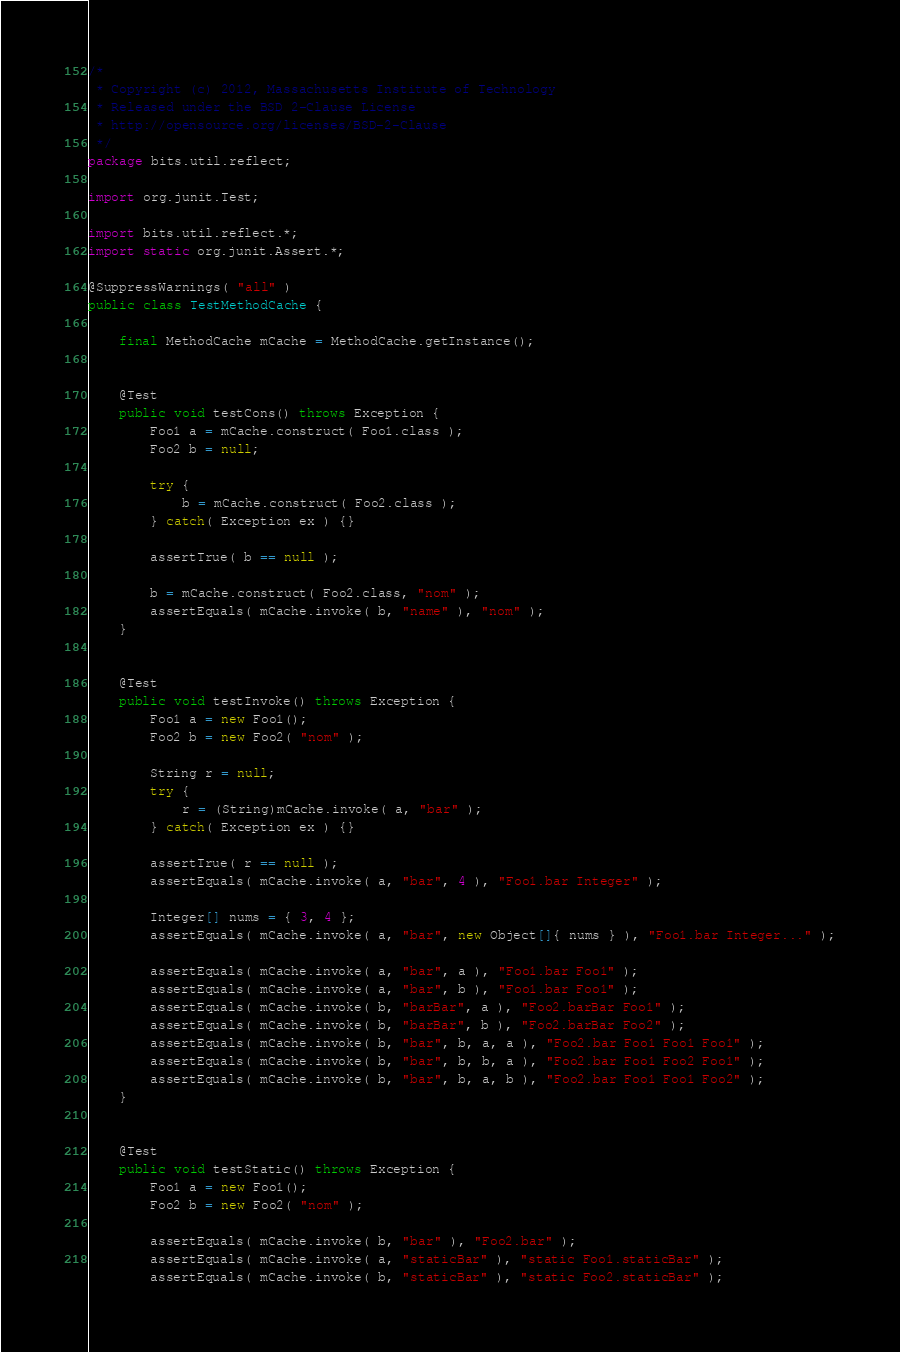<code> <loc_0><loc_0><loc_500><loc_500><_Java_>/* 
 * Copyright (c) 2012, Massachusetts Institute of Technology
 * Released under the BSD 2-Clause License
 * http://opensource.org/licenses/BSD-2-Clause 
 */ 
package bits.util.reflect;

import org.junit.Test;

import bits.util.reflect.*;
import static org.junit.Assert.*;

@SuppressWarnings( "all" )
public class TestMethodCache {
    
    final MethodCache mCache = MethodCache.getInstance();
    
    
    @Test
    public void testCons() throws Exception {
        Foo1 a = mCache.construct( Foo1.class );
        Foo2 b = null;
        
        try {
            b = mCache.construct( Foo2.class );
        } catch( Exception ex ) {}
        
        assertTrue( b == null );
        
        b = mCache.construct( Foo2.class, "nom" );
        assertEquals( mCache.invoke( b, "name" ), "nom" );
    }
    
    
    @Test
    public void testInvoke() throws Exception {
        Foo1 a = new Foo1();
        Foo2 b = new Foo2( "nom" );
        
        String r = null;
        try {
            r = (String)mCache.invoke( a, "bar" );
        } catch( Exception ex ) {}
        
        assertTrue( r == null );
        assertEquals( mCache.invoke( a, "bar", 4 ), "Foo1.bar Integer" );
        
        Integer[] nums = { 3, 4 };
        assertEquals( mCache.invoke( a, "bar", new Object[]{ nums } ), "Foo1.bar Integer..." );
        
        assertEquals( mCache.invoke( a, "bar", a ), "Foo1.bar Foo1" );
        assertEquals( mCache.invoke( a, "bar", b ), "Foo1.bar Foo1" );
        assertEquals( mCache.invoke( b, "barBar", a ), "Foo2.barBar Foo1" );
        assertEquals( mCache.invoke( b, "barBar", b ), "Foo2.barBar Foo2" );
        assertEquals( mCache.invoke( b, "bar", b, a, a ), "Foo2.bar Foo1 Foo1 Foo1" );
        assertEquals( mCache.invoke( b, "bar", b, b, a ), "Foo2.bar Foo1 Foo2 Foo1" );
        assertEquals( mCache.invoke( b, "bar", b, a, b ), "Foo2.bar Foo1 Foo1 Foo2" );
    }
    
    
    @Test
    public void testStatic() throws Exception {
        Foo1 a = new Foo1();
        Foo2 b = new Foo2( "nom" );
        
        assertEquals( mCache.invoke( b, "bar" ), "Foo2.bar" );
        assertEquals( mCache.invoke( a, "staticBar" ), "static Foo1.staticBar" );
        assertEquals( mCache.invoke( b, "staticBar" ), "static Foo2.staticBar" );</code> 